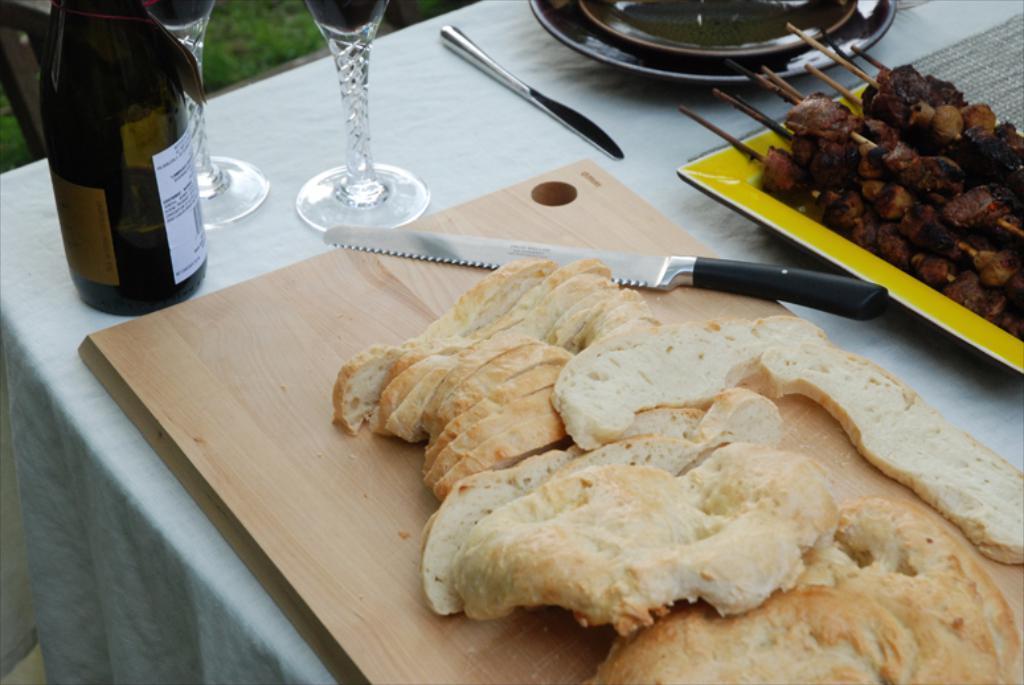In one or two sentences, can you explain what this image depicts? In the middle there is a table on the table there is a knife ,glass ,bottle ,bread ,tray ,cloth and some food items. At the bottom there is a grass. 